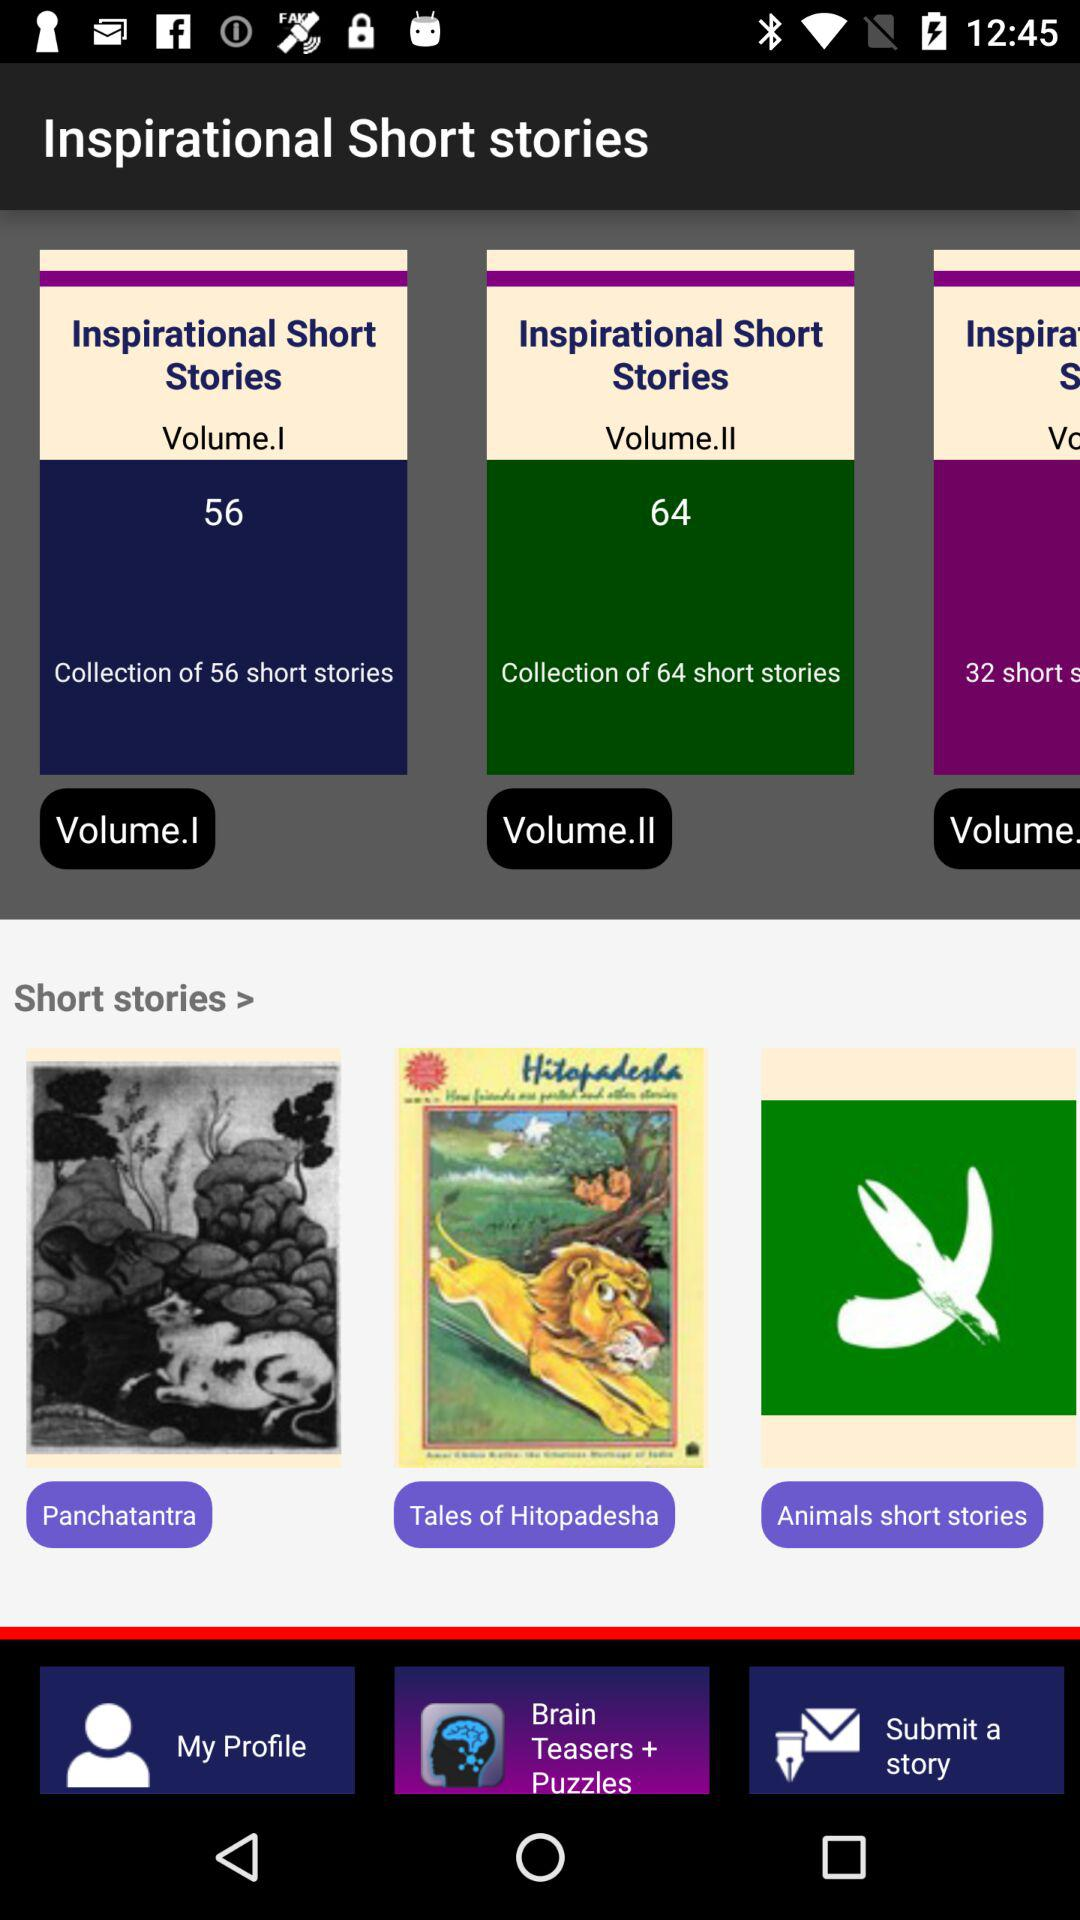How many stories are there in Inspirational Short Stories Volume II? There are 64 stories in Inspirational Short Stories Volume II. 